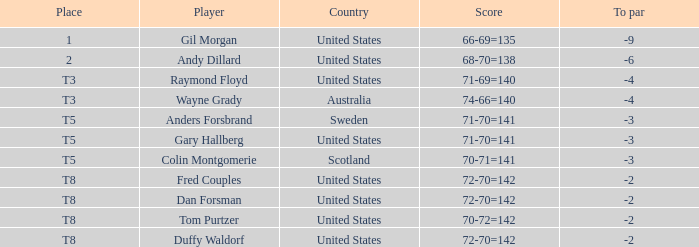What is Anders Forsbrand's Place? T5. 